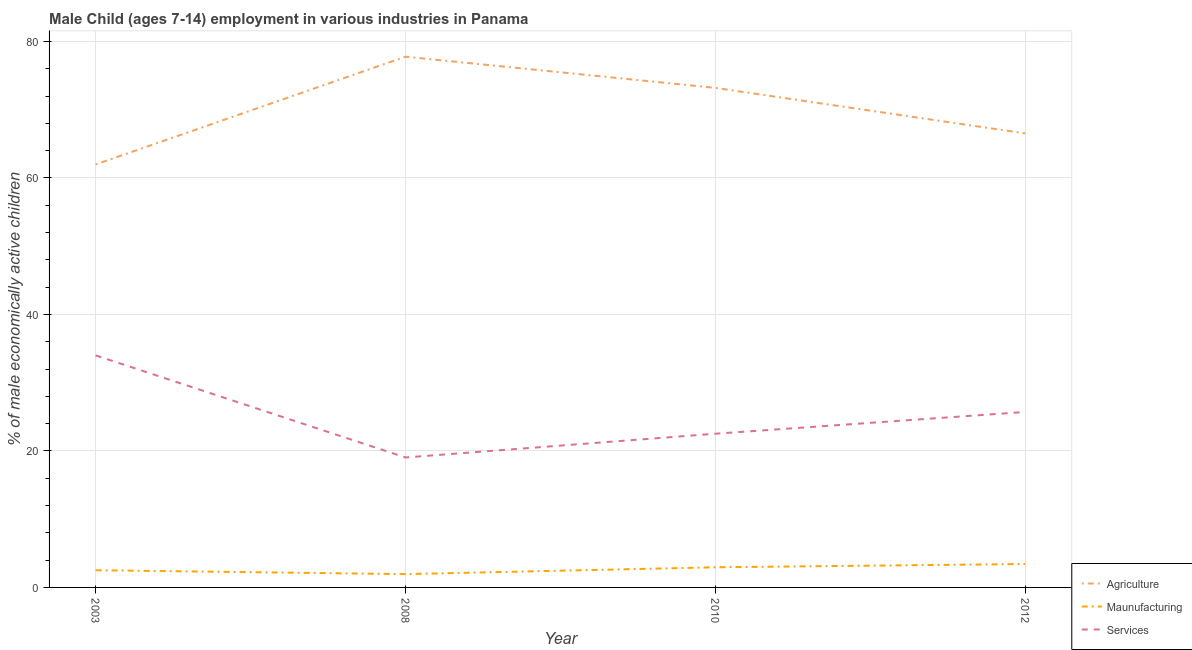Does the line corresponding to percentage of economically active children in manufacturing intersect with the line corresponding to percentage of economically active children in agriculture?
Provide a short and direct response. No. What is the percentage of economically active children in services in 2012?
Offer a very short reply. 25.71. Across all years, what is the minimum percentage of economically active children in services?
Ensure brevity in your answer.  19.04. In which year was the percentage of economically active children in agriculture minimum?
Your answer should be very brief. 2003. What is the total percentage of economically active children in agriculture in the graph?
Your answer should be very brief. 279.44. What is the difference between the percentage of economically active children in manufacturing in 2003 and that in 2010?
Offer a terse response. -0.43. What is the difference between the percentage of economically active children in manufacturing in 2012 and the percentage of economically active children in agriculture in 2010?
Offer a very short reply. -69.76. What is the average percentage of economically active children in agriculture per year?
Your answer should be very brief. 69.86. In the year 2010, what is the difference between the percentage of economically active children in manufacturing and percentage of economically active children in agriculture?
Offer a very short reply. -70.24. What is the ratio of the percentage of economically active children in services in 2003 to that in 2010?
Your response must be concise. 1.51. Is the percentage of economically active children in services in 2008 less than that in 2012?
Provide a succinct answer. Yes. Is the difference between the percentage of economically active children in agriculture in 2008 and 2012 greater than the difference between the percentage of economically active children in services in 2008 and 2012?
Provide a succinct answer. Yes. What is the difference between the highest and the second highest percentage of economically active children in manufacturing?
Keep it short and to the point. 0.48. What is the difference between the highest and the lowest percentage of economically active children in services?
Offer a terse response. 14.96. Does the percentage of economically active children in manufacturing monotonically increase over the years?
Your answer should be very brief. No. Is the percentage of economically active children in manufacturing strictly greater than the percentage of economically active children in agriculture over the years?
Provide a short and direct response. No. Is the percentage of economically active children in manufacturing strictly less than the percentage of economically active children in agriculture over the years?
Offer a very short reply. Yes. How many years are there in the graph?
Offer a very short reply. 4. What is the difference between two consecutive major ticks on the Y-axis?
Offer a terse response. 20. How many legend labels are there?
Your answer should be compact. 3. What is the title of the graph?
Keep it short and to the point. Male Child (ages 7-14) employment in various industries in Panama. What is the label or title of the X-axis?
Keep it short and to the point. Year. What is the label or title of the Y-axis?
Provide a short and direct response. % of male economically active children. What is the % of male economically active children of Agriculture in 2003?
Your answer should be very brief. 61.97. What is the % of male economically active children in Maunufacturing in 2003?
Ensure brevity in your answer.  2.52. What is the % of male economically active children of Agriculture in 2008?
Provide a short and direct response. 77.76. What is the % of male economically active children of Maunufacturing in 2008?
Your answer should be compact. 1.95. What is the % of male economically active children in Services in 2008?
Ensure brevity in your answer.  19.04. What is the % of male economically active children in Agriculture in 2010?
Your response must be concise. 73.19. What is the % of male economically active children in Maunufacturing in 2010?
Provide a succinct answer. 2.95. What is the % of male economically active children of Services in 2010?
Your response must be concise. 22.52. What is the % of male economically active children in Agriculture in 2012?
Provide a short and direct response. 66.52. What is the % of male economically active children of Maunufacturing in 2012?
Make the answer very short. 3.43. What is the % of male economically active children of Services in 2012?
Your response must be concise. 25.71. Across all years, what is the maximum % of male economically active children in Agriculture?
Provide a succinct answer. 77.76. Across all years, what is the maximum % of male economically active children in Maunufacturing?
Your answer should be very brief. 3.43. Across all years, what is the maximum % of male economically active children in Services?
Ensure brevity in your answer.  34. Across all years, what is the minimum % of male economically active children in Agriculture?
Make the answer very short. 61.97. Across all years, what is the minimum % of male economically active children in Maunufacturing?
Keep it short and to the point. 1.95. Across all years, what is the minimum % of male economically active children in Services?
Provide a short and direct response. 19.04. What is the total % of male economically active children of Agriculture in the graph?
Make the answer very short. 279.44. What is the total % of male economically active children of Maunufacturing in the graph?
Give a very brief answer. 10.85. What is the total % of male economically active children of Services in the graph?
Your answer should be compact. 101.27. What is the difference between the % of male economically active children of Agriculture in 2003 and that in 2008?
Your answer should be very brief. -15.79. What is the difference between the % of male economically active children of Maunufacturing in 2003 and that in 2008?
Give a very brief answer. 0.57. What is the difference between the % of male economically active children of Services in 2003 and that in 2008?
Give a very brief answer. 14.96. What is the difference between the % of male economically active children of Agriculture in 2003 and that in 2010?
Offer a terse response. -11.22. What is the difference between the % of male economically active children of Maunufacturing in 2003 and that in 2010?
Offer a very short reply. -0.43. What is the difference between the % of male economically active children in Services in 2003 and that in 2010?
Offer a very short reply. 11.48. What is the difference between the % of male economically active children of Agriculture in 2003 and that in 2012?
Offer a very short reply. -4.55. What is the difference between the % of male economically active children of Maunufacturing in 2003 and that in 2012?
Provide a succinct answer. -0.91. What is the difference between the % of male economically active children in Services in 2003 and that in 2012?
Offer a terse response. 8.29. What is the difference between the % of male economically active children of Agriculture in 2008 and that in 2010?
Your answer should be very brief. 4.57. What is the difference between the % of male economically active children in Services in 2008 and that in 2010?
Make the answer very short. -3.48. What is the difference between the % of male economically active children in Agriculture in 2008 and that in 2012?
Your response must be concise. 11.24. What is the difference between the % of male economically active children of Maunufacturing in 2008 and that in 2012?
Make the answer very short. -1.48. What is the difference between the % of male economically active children in Services in 2008 and that in 2012?
Keep it short and to the point. -6.67. What is the difference between the % of male economically active children in Agriculture in 2010 and that in 2012?
Ensure brevity in your answer.  6.67. What is the difference between the % of male economically active children of Maunufacturing in 2010 and that in 2012?
Your response must be concise. -0.48. What is the difference between the % of male economically active children of Services in 2010 and that in 2012?
Provide a succinct answer. -3.19. What is the difference between the % of male economically active children of Agriculture in 2003 and the % of male economically active children of Maunufacturing in 2008?
Give a very brief answer. 60.02. What is the difference between the % of male economically active children in Agriculture in 2003 and the % of male economically active children in Services in 2008?
Offer a very short reply. 42.93. What is the difference between the % of male economically active children of Maunufacturing in 2003 and the % of male economically active children of Services in 2008?
Offer a very short reply. -16.52. What is the difference between the % of male economically active children in Agriculture in 2003 and the % of male economically active children in Maunufacturing in 2010?
Your answer should be very brief. 59.02. What is the difference between the % of male economically active children in Agriculture in 2003 and the % of male economically active children in Services in 2010?
Provide a short and direct response. 39.45. What is the difference between the % of male economically active children of Agriculture in 2003 and the % of male economically active children of Maunufacturing in 2012?
Keep it short and to the point. 58.54. What is the difference between the % of male economically active children in Agriculture in 2003 and the % of male economically active children in Services in 2012?
Ensure brevity in your answer.  36.26. What is the difference between the % of male economically active children of Maunufacturing in 2003 and the % of male economically active children of Services in 2012?
Make the answer very short. -23.19. What is the difference between the % of male economically active children of Agriculture in 2008 and the % of male economically active children of Maunufacturing in 2010?
Give a very brief answer. 74.81. What is the difference between the % of male economically active children in Agriculture in 2008 and the % of male economically active children in Services in 2010?
Provide a succinct answer. 55.24. What is the difference between the % of male economically active children in Maunufacturing in 2008 and the % of male economically active children in Services in 2010?
Your response must be concise. -20.57. What is the difference between the % of male economically active children in Agriculture in 2008 and the % of male economically active children in Maunufacturing in 2012?
Your answer should be very brief. 74.33. What is the difference between the % of male economically active children of Agriculture in 2008 and the % of male economically active children of Services in 2012?
Provide a succinct answer. 52.05. What is the difference between the % of male economically active children in Maunufacturing in 2008 and the % of male economically active children in Services in 2012?
Offer a terse response. -23.76. What is the difference between the % of male economically active children in Agriculture in 2010 and the % of male economically active children in Maunufacturing in 2012?
Ensure brevity in your answer.  69.76. What is the difference between the % of male economically active children in Agriculture in 2010 and the % of male economically active children in Services in 2012?
Give a very brief answer. 47.48. What is the difference between the % of male economically active children in Maunufacturing in 2010 and the % of male economically active children in Services in 2012?
Your answer should be very brief. -22.76. What is the average % of male economically active children in Agriculture per year?
Provide a short and direct response. 69.86. What is the average % of male economically active children of Maunufacturing per year?
Offer a terse response. 2.71. What is the average % of male economically active children of Services per year?
Ensure brevity in your answer.  25.32. In the year 2003, what is the difference between the % of male economically active children in Agriculture and % of male economically active children in Maunufacturing?
Give a very brief answer. 59.45. In the year 2003, what is the difference between the % of male economically active children of Agriculture and % of male economically active children of Services?
Your answer should be compact. 27.97. In the year 2003, what is the difference between the % of male economically active children in Maunufacturing and % of male economically active children in Services?
Provide a succinct answer. -31.48. In the year 2008, what is the difference between the % of male economically active children of Agriculture and % of male economically active children of Maunufacturing?
Give a very brief answer. 75.81. In the year 2008, what is the difference between the % of male economically active children in Agriculture and % of male economically active children in Services?
Your answer should be very brief. 58.72. In the year 2008, what is the difference between the % of male economically active children in Maunufacturing and % of male economically active children in Services?
Keep it short and to the point. -17.09. In the year 2010, what is the difference between the % of male economically active children of Agriculture and % of male economically active children of Maunufacturing?
Make the answer very short. 70.24. In the year 2010, what is the difference between the % of male economically active children in Agriculture and % of male economically active children in Services?
Your response must be concise. 50.67. In the year 2010, what is the difference between the % of male economically active children in Maunufacturing and % of male economically active children in Services?
Offer a terse response. -19.57. In the year 2012, what is the difference between the % of male economically active children in Agriculture and % of male economically active children in Maunufacturing?
Your answer should be very brief. 63.09. In the year 2012, what is the difference between the % of male economically active children in Agriculture and % of male economically active children in Services?
Your answer should be compact. 40.81. In the year 2012, what is the difference between the % of male economically active children of Maunufacturing and % of male economically active children of Services?
Your answer should be very brief. -22.28. What is the ratio of the % of male economically active children in Agriculture in 2003 to that in 2008?
Your response must be concise. 0.8. What is the ratio of the % of male economically active children of Maunufacturing in 2003 to that in 2008?
Provide a succinct answer. 1.29. What is the ratio of the % of male economically active children in Services in 2003 to that in 2008?
Give a very brief answer. 1.79. What is the ratio of the % of male economically active children in Agriculture in 2003 to that in 2010?
Your response must be concise. 0.85. What is the ratio of the % of male economically active children in Maunufacturing in 2003 to that in 2010?
Your answer should be compact. 0.85. What is the ratio of the % of male economically active children of Services in 2003 to that in 2010?
Offer a very short reply. 1.51. What is the ratio of the % of male economically active children of Agriculture in 2003 to that in 2012?
Provide a succinct answer. 0.93. What is the ratio of the % of male economically active children in Maunufacturing in 2003 to that in 2012?
Keep it short and to the point. 0.73. What is the ratio of the % of male economically active children in Services in 2003 to that in 2012?
Offer a terse response. 1.32. What is the ratio of the % of male economically active children of Agriculture in 2008 to that in 2010?
Provide a succinct answer. 1.06. What is the ratio of the % of male economically active children of Maunufacturing in 2008 to that in 2010?
Provide a succinct answer. 0.66. What is the ratio of the % of male economically active children in Services in 2008 to that in 2010?
Your answer should be very brief. 0.85. What is the ratio of the % of male economically active children in Agriculture in 2008 to that in 2012?
Make the answer very short. 1.17. What is the ratio of the % of male economically active children in Maunufacturing in 2008 to that in 2012?
Give a very brief answer. 0.57. What is the ratio of the % of male economically active children in Services in 2008 to that in 2012?
Provide a short and direct response. 0.74. What is the ratio of the % of male economically active children in Agriculture in 2010 to that in 2012?
Make the answer very short. 1.1. What is the ratio of the % of male economically active children in Maunufacturing in 2010 to that in 2012?
Ensure brevity in your answer.  0.86. What is the ratio of the % of male economically active children of Services in 2010 to that in 2012?
Provide a succinct answer. 0.88. What is the difference between the highest and the second highest % of male economically active children in Agriculture?
Keep it short and to the point. 4.57. What is the difference between the highest and the second highest % of male economically active children of Maunufacturing?
Ensure brevity in your answer.  0.48. What is the difference between the highest and the second highest % of male economically active children of Services?
Make the answer very short. 8.29. What is the difference between the highest and the lowest % of male economically active children of Agriculture?
Provide a short and direct response. 15.79. What is the difference between the highest and the lowest % of male economically active children in Maunufacturing?
Provide a short and direct response. 1.48. What is the difference between the highest and the lowest % of male economically active children of Services?
Your response must be concise. 14.96. 